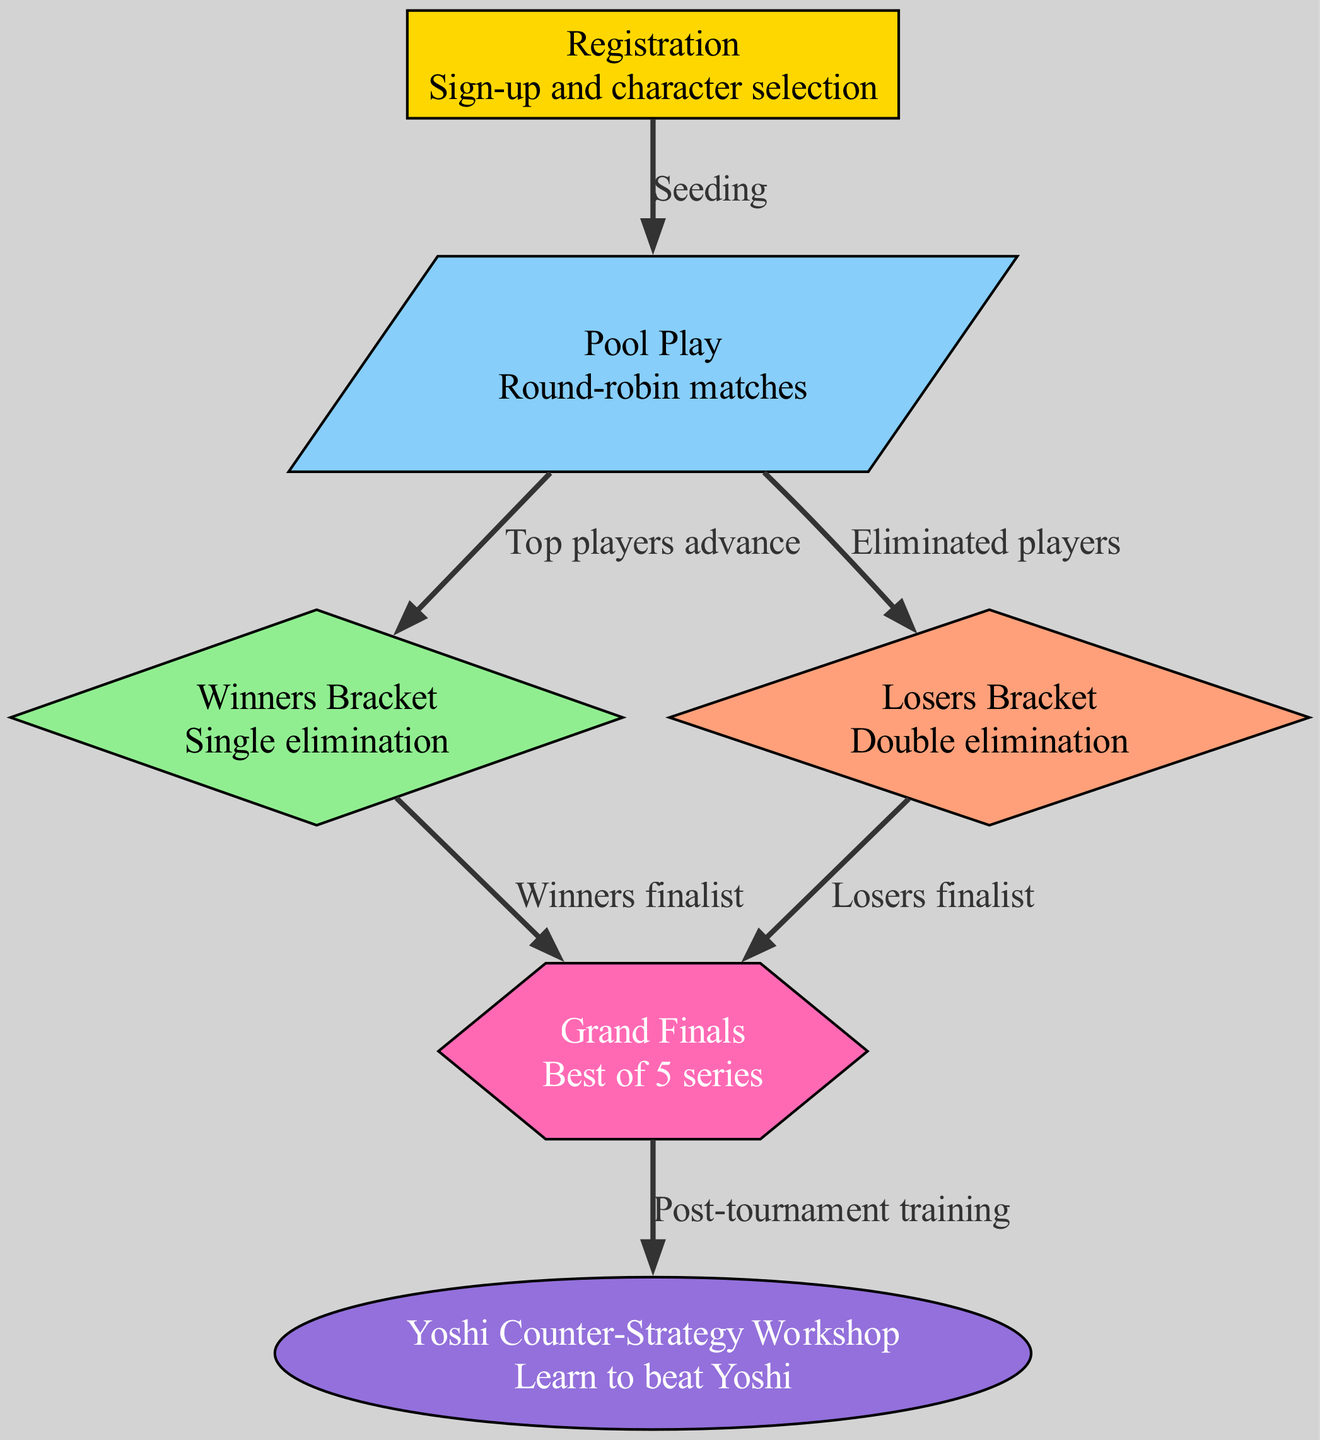What is the starting point of the tournament process? The diagram shows that the first node is "Registration," indicating that it is the initial step where players sign up and select their characters.
Answer: Registration How many nodes are present in the diagram? By counting the nodes listed in the diagram, there are a total of six distinct nodes representing different stages of the tournament process.
Answer: 6 What happens to players eliminated in Pool Play? The diagram indicates that eliminated players from Pool Play proceed to the "Losers Bracket," suggesting a double elimination format for those who do not make it to the Winners Bracket.
Answer: Losers Bracket What type of matches occur in the Winners Bracket? The diagram specifies that matches in the Winners Bracket are categorized as single elimination, meaning players can only lose once before being eliminated from this bracket.
Answer: Single elimination What is the final stage of the tournament called? According to the diagram, the last competitive stage of the tournament is referred to as "Grand Finals," which is the decisive match series to determine the overall champion.
Answer: Grand Finals What does the label from Winners Bracket to Grand Finals signify? The edge connecting the Winners Bracket to the Grand Finals indicates that the participant who emerges as the finalist from the Winners Bracket advances to this final stage of the tournament.
Answer: Winners finalist What additional resource is offered after the Grand Finals? The diagram illustrates that after the Grand Finals, there is a "Yoshi Counter-Strategy Workshop," providing players an opportunity for post-tournament training specifically aimed at improving against Yoshi players.
Answer: Yoshi Counter-Strategy Workshop How do players transition from Pool Play to the Winners Bracket? The edge labeled "Top players advance" indicates that the players who performed well in Pool Play will be seeded into the Winners Bracket for the next stage of the competition.
Answer: Top players advance What describes the format of the Losers Bracket? The diagram describes the Losers Bracket as having a "Double elimination" format, allowing players a second chance to compete after their first loss.
Answer: Double elimination 